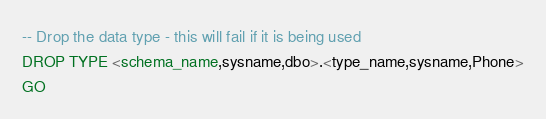<code> <loc_0><loc_0><loc_500><loc_500><_SQL_>
-- Drop the data type - this will fail if it is being used
DROP TYPE <schema_name,sysname,dbo>.<type_name,sysname,Phone>
GO
</code> 